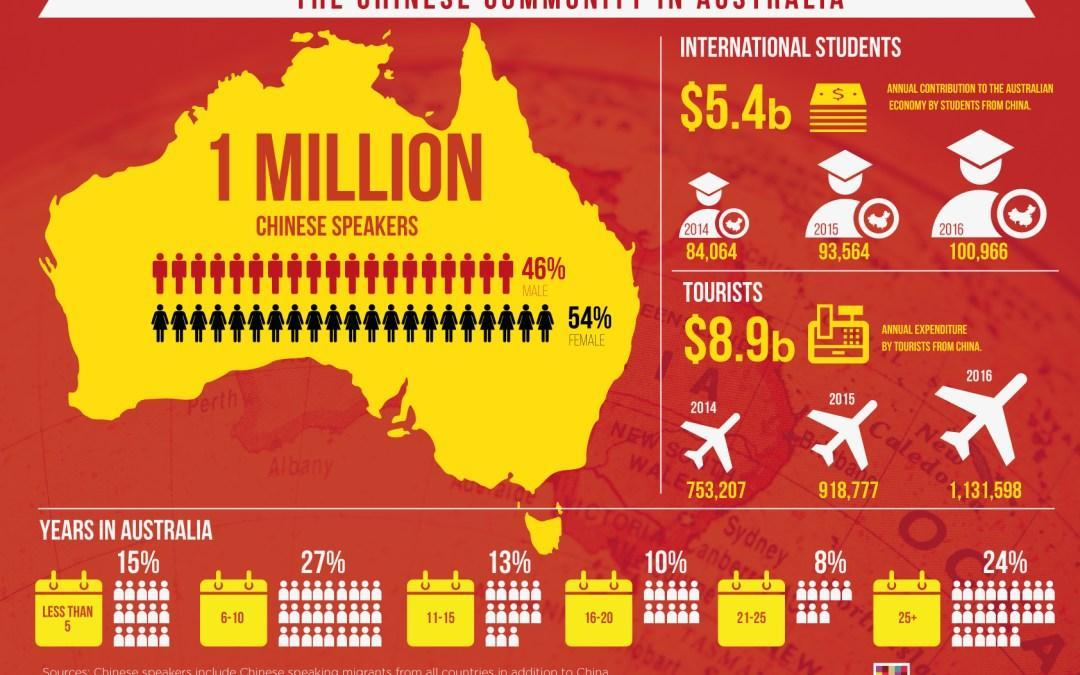What is the annual contribution to the Australian economy by students from china in 2015?
Answer the question with a short phrase. 93,564 What percent of Chinese people lived in Australia for 16-20 years? 10% What percentage of  Chinese speakers in Australia are males? 46% What percent of Chinese people lived in Australia for 25+ years? 24% What is the annual contribution to the Australian economy by students from china in 2016? 100,966 What percent of Chinese people lived in Australia for 6-10 years? 27% What percentage of Chinese speakers in Australia are females? 54% What is the annual expenditure by tourists from china in 2016? 1,131,598 What is the annual expenditure by tourists from china in 2015? 918,777 